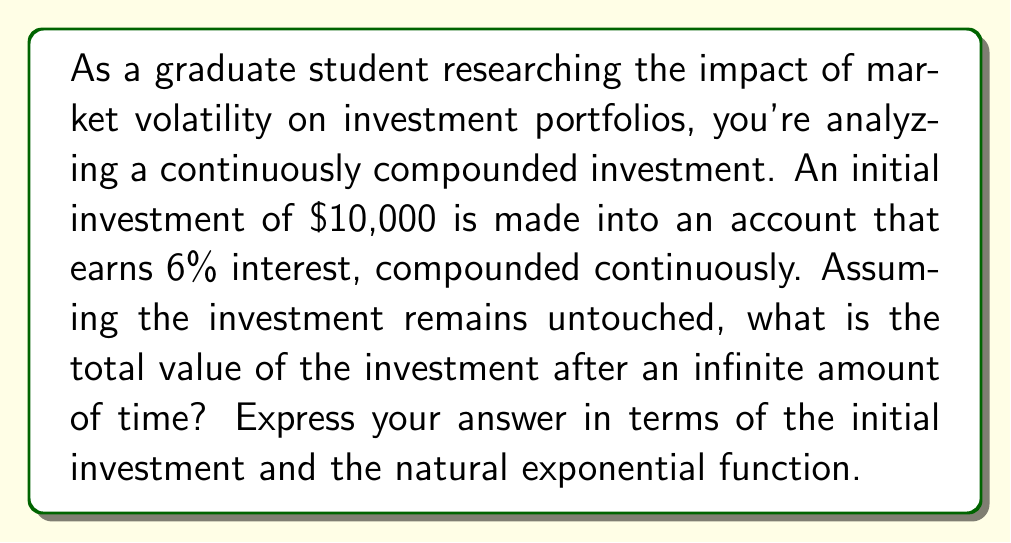What is the answer to this math problem? To solve this problem, we need to use the concept of infinite geometric series and the formula for continuous compound interest.

1) The formula for continuous compound interest is:

   $A = P e^{rt}$

   Where:
   $A$ = final amount
   $P$ = principal (initial investment)
   $e$ = natural exponential function
   $r$ = interest rate (as a decimal)
   $t$ = time in years

2) In this case, we're looking at an infinite time horizon, so $t$ approaches infinity. As $t$ approaches infinity, $e^{rt}$ becomes infinitely large.

3) However, we can think of this as an infinite geometric series. Each infinitesimal time period, the investment grows by a factor of $e^{r dt}$.

4) The sum of an infinite geometric series is given by:

   $S_{\infty} = \frac{a}{1-r}$

   Where $a$ is the first term and $r$ is the common ratio.

5) In our case, the first term $a$ is the initial investment $P$, and the common ratio is $e^r$ (as we're looking at a unit time period).

6) Therefore, our sum becomes:

   $S_{\infty} = \frac{P}{1-e^r}$

7) However, since $r$ is positive (6% or 0.06), $e^r > 1$, which means $1-e^r$ is negative.

8) The correct interpretation is that as time approaches infinity, the value of the investment approaches positive infinity.

Therefore, there is no finite sum for this infinite series. The investment will grow without bound as time approaches infinity.
Answer: The value of the investment approaches positive infinity as time approaches infinity. There is no finite sum for this infinite series. 